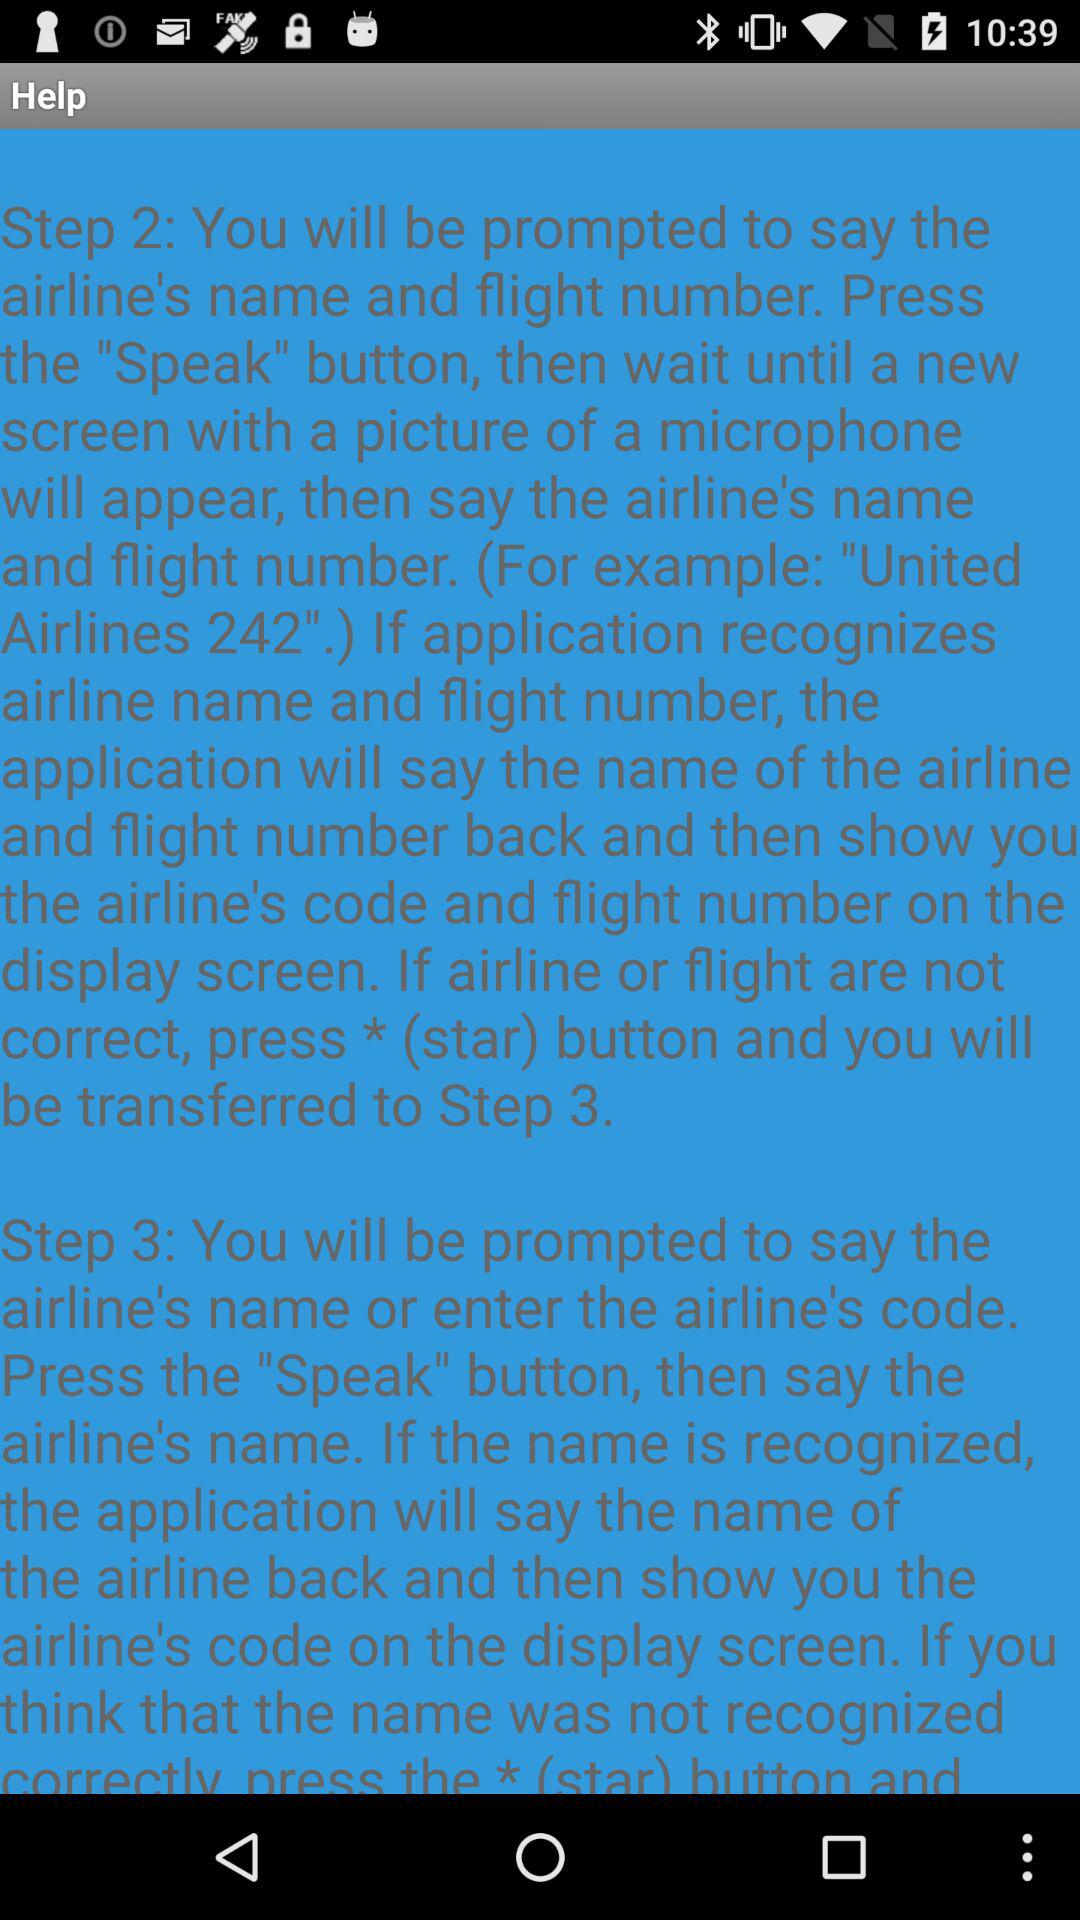How many steps are there in the help article?
Answer the question using a single word or phrase. 3 